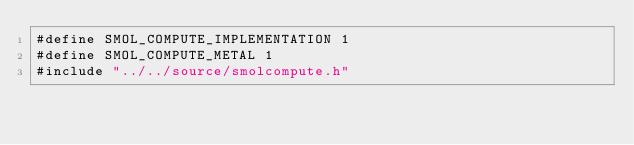Convert code to text. <code><loc_0><loc_0><loc_500><loc_500><_ObjectiveC_>#define SMOL_COMPUTE_IMPLEMENTATION 1
#define SMOL_COMPUTE_METAL 1
#include "../../source/smolcompute.h"
</code> 